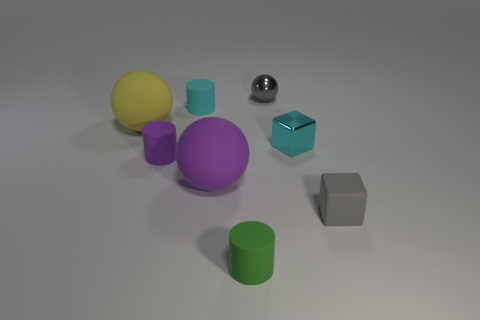Add 2 big blue shiny blocks. How many objects exist? 10 Subtract all cylinders. How many objects are left? 5 Add 2 small purple matte cylinders. How many small purple matte cylinders are left? 3 Add 8 cyan metal things. How many cyan metal things exist? 9 Subtract 0 blue spheres. How many objects are left? 8 Subtract all big purple shiny cylinders. Subtract all small cylinders. How many objects are left? 5 